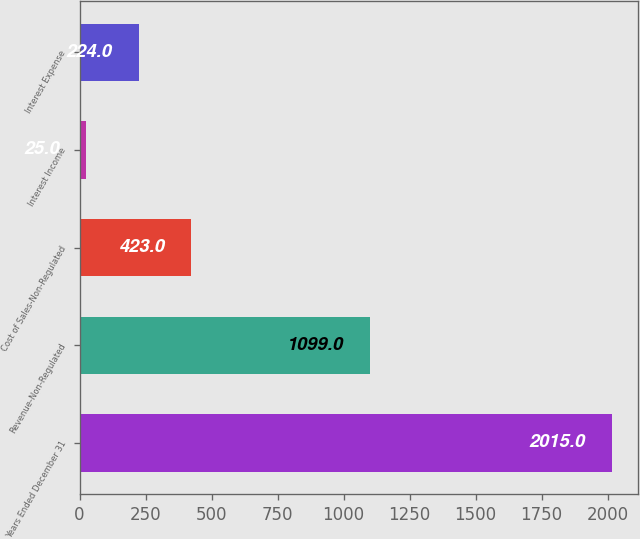Convert chart to OTSL. <chart><loc_0><loc_0><loc_500><loc_500><bar_chart><fcel>Years Ended December 31<fcel>Revenue-Non-Regulated<fcel>Cost of Sales-Non-Regulated<fcel>Interest Income<fcel>Interest Expense<nl><fcel>2015<fcel>1099<fcel>423<fcel>25<fcel>224<nl></chart> 